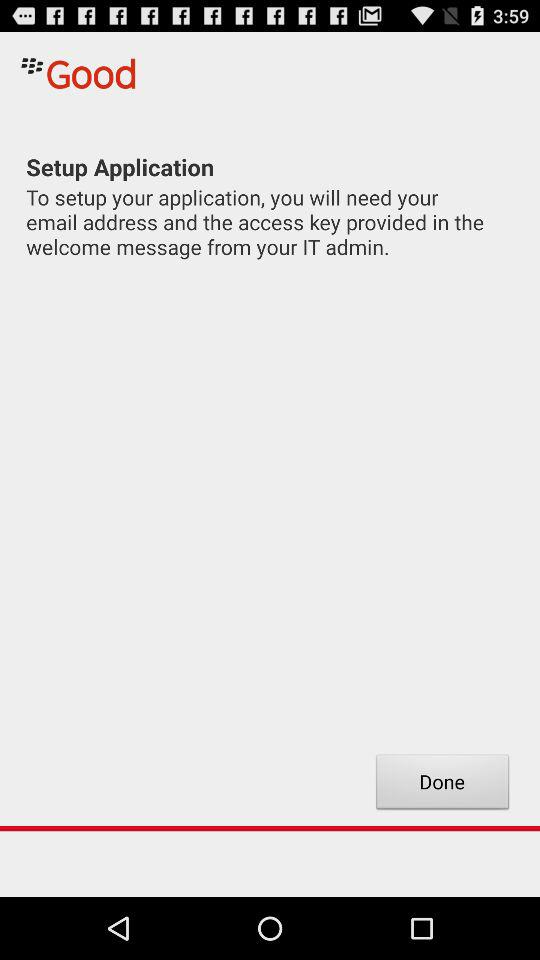What is the email address?
When the provided information is insufficient, respond with <no answer>. <no answer> 